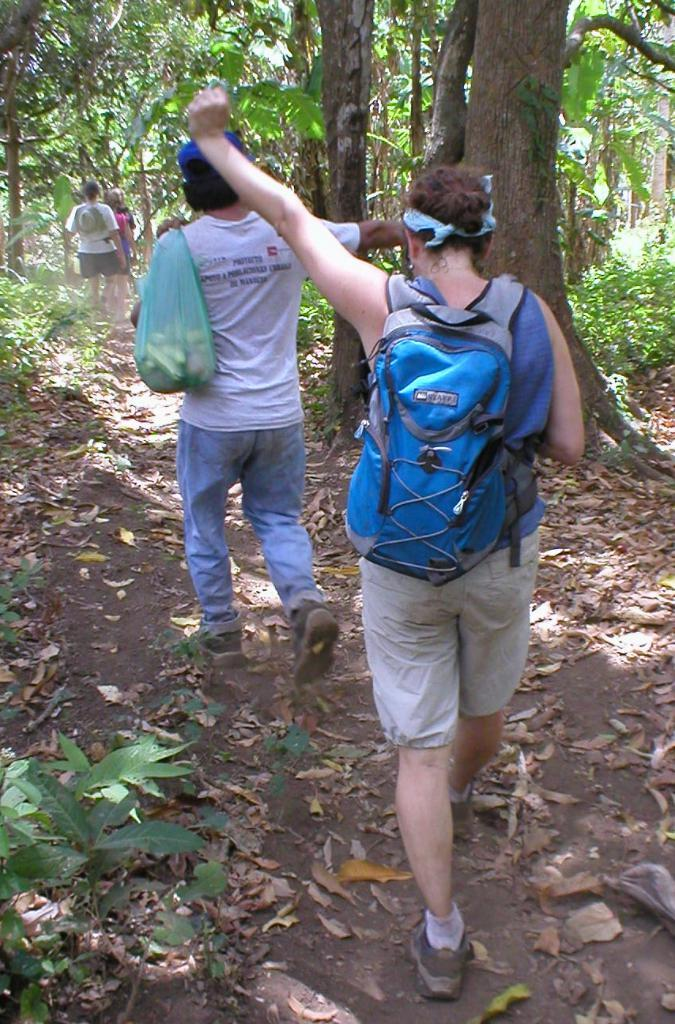What are the people in the image doing? The people in the image are walking. Where are the people walking? The people are walking on a road. Can you describe the man in the image? The man in the image is wearing a bag. What can be seen in the background of the image? There are trees visible in the background of the image. What type of flower can be seen growing on the side of the road in the image? There is no flower visible on the side of the road in the image. How many clocks are present in the image? There are no clocks present in the image. 